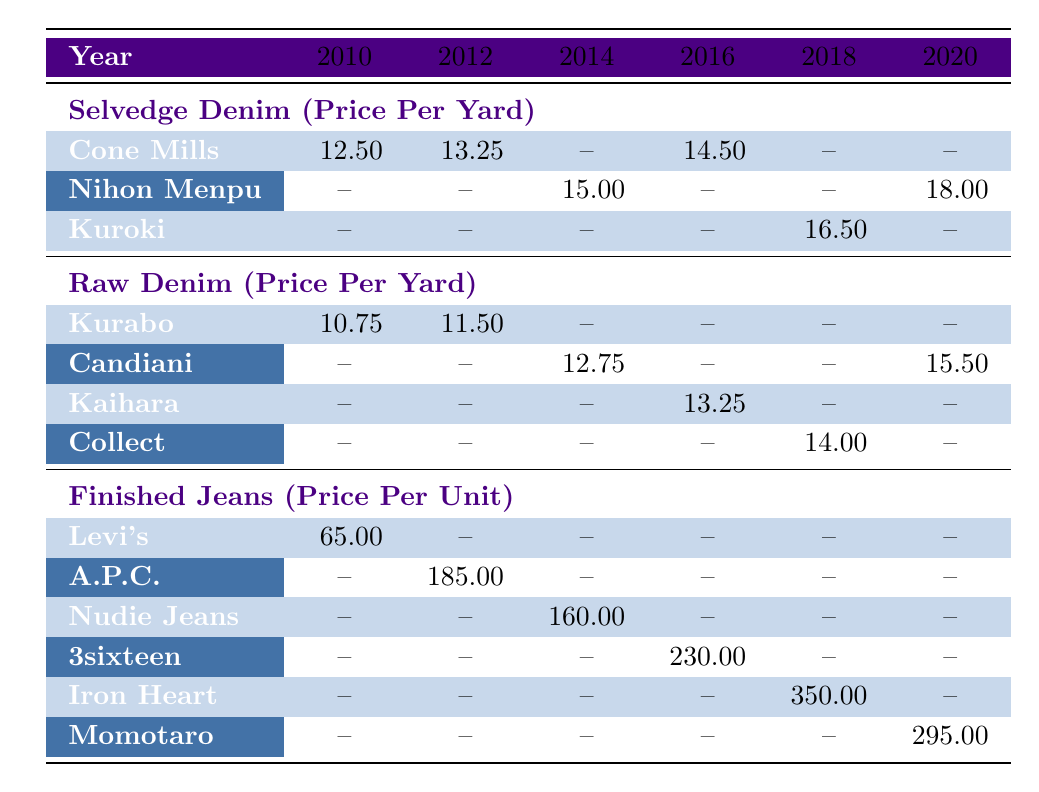What was the price per yard of Selvedge Denim from Cone Mills in 2012? The table shows that the price per yard for Selvedge Denim from Cone Mills in 2012 is listed under the 2012 column corresponding to that brand, and the value is 13.25.
Answer: 13.25 What is the highest price per unit for Finished Jeans and which brand offers it? Looking at the Finished Jeans row, the highest price listed is 350.00 for the brand Iron Heart, found in the 2018 column.
Answer: 350.00, Iron Heart Did Raw Denim from Kurabo ever reach a price higher than 12.00 per yard? By examining the prices in the Raw Denim section, Kurabo's prices are 10.75 in 2010 and 11.50 in 2012; neither is higher than 12.00. Thus, the statement is false.
Answer: No What is the average price per yard of Selvedge Denim across the years provided? The Selvedge Denim prices are 12.50 (2010), 13.25 (2012), 14.50 (2016), and 18.00 (2020). To find the average, sum these values (12.50 + 13.25 + 14.50 + 18.00 = 58.25) and divide by 4, which equals 14.56.
Answer: 14.56 Was there any year when Finished Jeans had no recorded price? The table shows that in 2010, 2012, and 2014, there are prices listed, but 2016 is blank. Thus, the statement is true.
Answer: Yes What was the increase in price per yard of Selvedge Denim from Cone Mills from 2010 to 2016? The price in 2010 was 12.50 and increased to 14.50 in 2016. The increase is calculated as 14.50 - 12.50 = 2.00.
Answer: 2.00 Which brand of Raw Denim had the highest price in 2020? Checking the Raw Denim section for 2020, Candiani is listed with a price of 15.50, and no other brand's price is recorded for that year, making it the highest.
Answer: Candiani What is the price difference between the highest and lowest priced Finished Jeans? The highest price is 350.00 (Iron Heart) and the lowest is 65.00 (Levi's), giving a difference of 350.00 - 65.00 = 285.00.
Answer: 285.00 